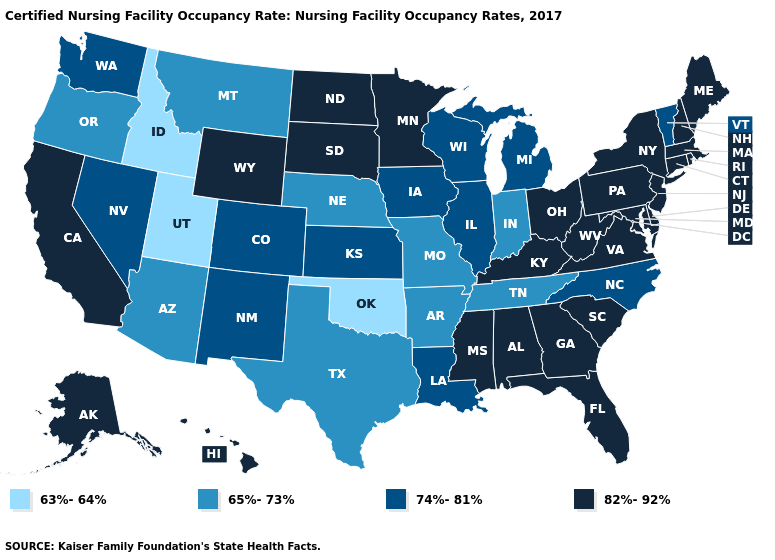What is the value of South Carolina?
Write a very short answer. 82%-92%. How many symbols are there in the legend?
Quick response, please. 4. What is the lowest value in the USA?
Answer briefly. 63%-64%. Among the states that border Iowa , which have the highest value?
Concise answer only. Minnesota, South Dakota. What is the value of Kentucky?
Answer briefly. 82%-92%. Name the states that have a value in the range 65%-73%?
Be succinct. Arizona, Arkansas, Indiana, Missouri, Montana, Nebraska, Oregon, Tennessee, Texas. What is the value of Oklahoma?
Quick response, please. 63%-64%. Name the states that have a value in the range 82%-92%?
Quick response, please. Alabama, Alaska, California, Connecticut, Delaware, Florida, Georgia, Hawaii, Kentucky, Maine, Maryland, Massachusetts, Minnesota, Mississippi, New Hampshire, New Jersey, New York, North Dakota, Ohio, Pennsylvania, Rhode Island, South Carolina, South Dakota, Virginia, West Virginia, Wyoming. What is the highest value in the MidWest ?
Write a very short answer. 82%-92%. Does Oklahoma have the highest value in the USA?
Short answer required. No. How many symbols are there in the legend?
Keep it brief. 4. What is the value of Mississippi?
Write a very short answer. 82%-92%. What is the value of Oregon?
Write a very short answer. 65%-73%. What is the value of New Jersey?
Short answer required. 82%-92%. 